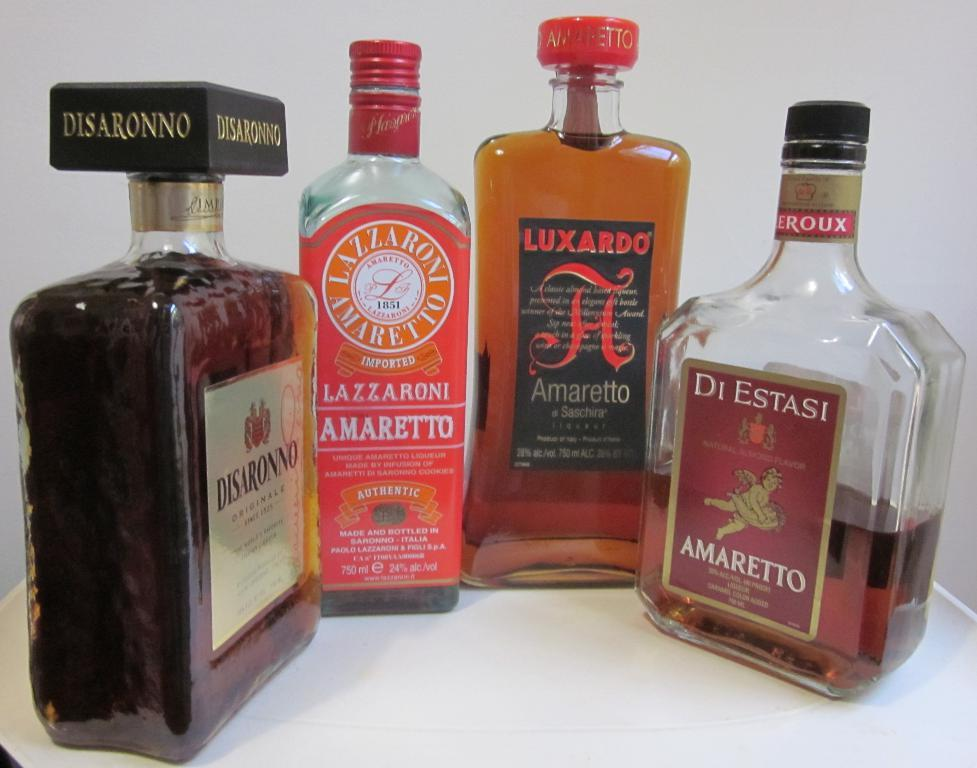What is located at the bottom of the image? There is a table at the bottom of the image. What objects are on the table? There are four bottles on the table. How much profit does the tree in the image generate? There is no tree present in the image, so it is not possible to determine any profit generated. 